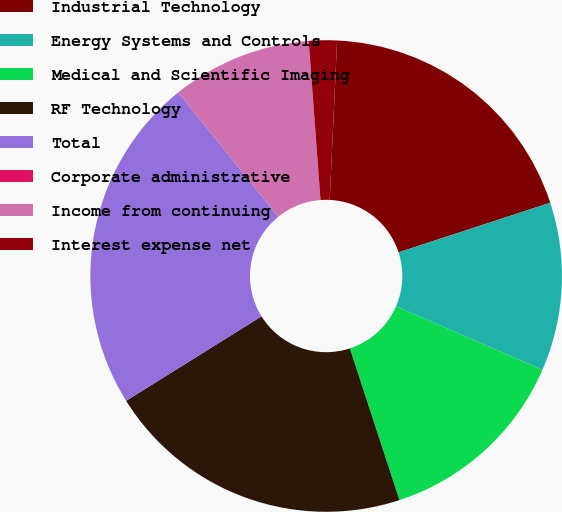<chart> <loc_0><loc_0><loc_500><loc_500><pie_chart><fcel>Industrial Technology<fcel>Energy Systems and Controls<fcel>Medical and Scientific Imaging<fcel>RF Technology<fcel>Total<fcel>Corporate administrative<fcel>Income from continuing<fcel>Interest expense net<nl><fcel>19.23%<fcel>11.54%<fcel>13.46%<fcel>21.15%<fcel>23.08%<fcel>0.0%<fcel>9.62%<fcel>1.92%<nl></chart> 